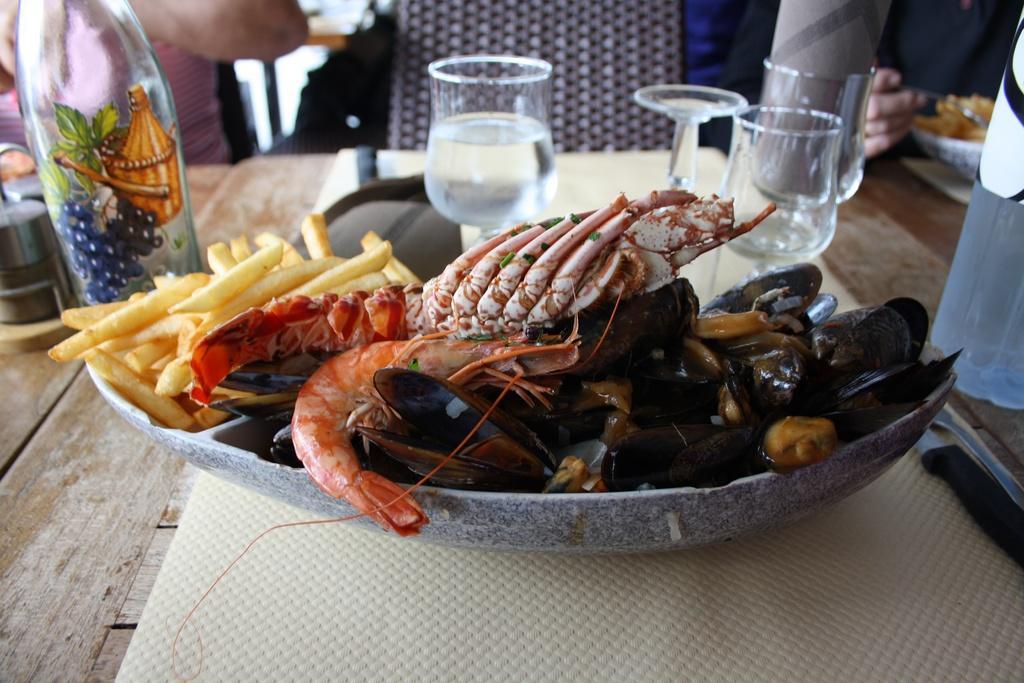In one or two sentences, can you explain what this image depicts? In the left side these are the french fries. In the middle these are the prawns in a plate and here are the wine glasses. 